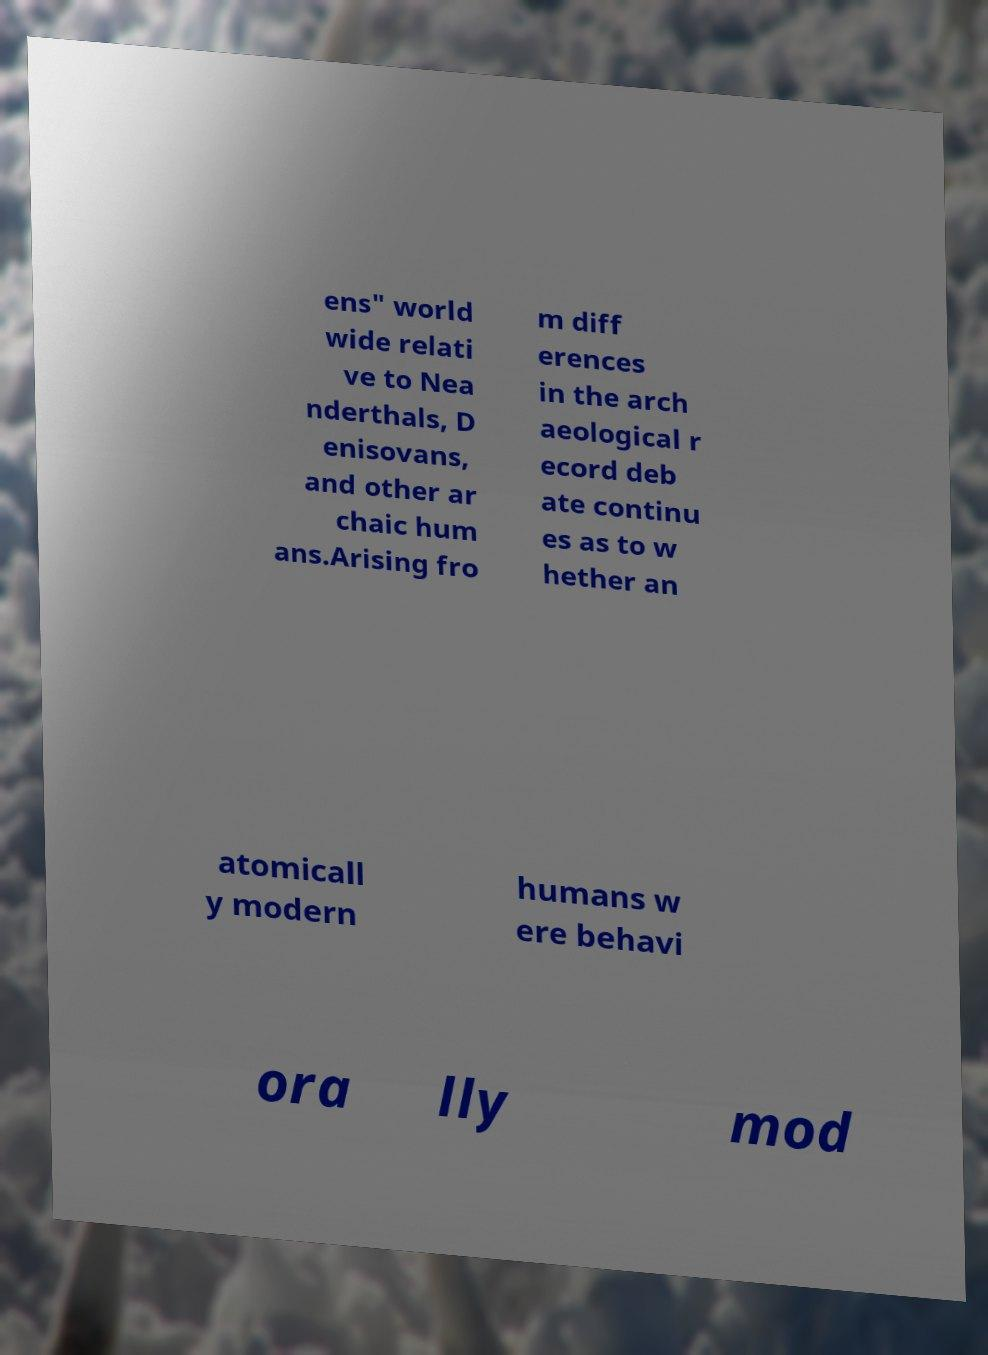There's text embedded in this image that I need extracted. Can you transcribe it verbatim? ens" world wide relati ve to Nea nderthals, D enisovans, and other ar chaic hum ans.Arising fro m diff erences in the arch aeological r ecord deb ate continu es as to w hether an atomicall y modern humans w ere behavi ora lly mod 